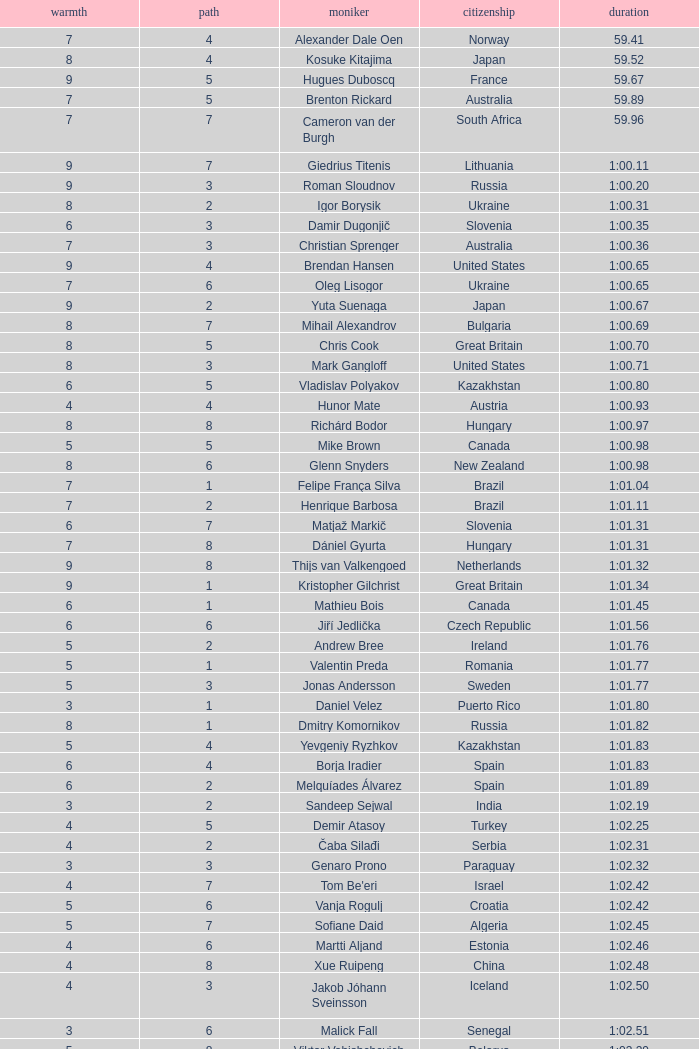What is the smallest lane number of Xue Ruipeng? 8.0. 